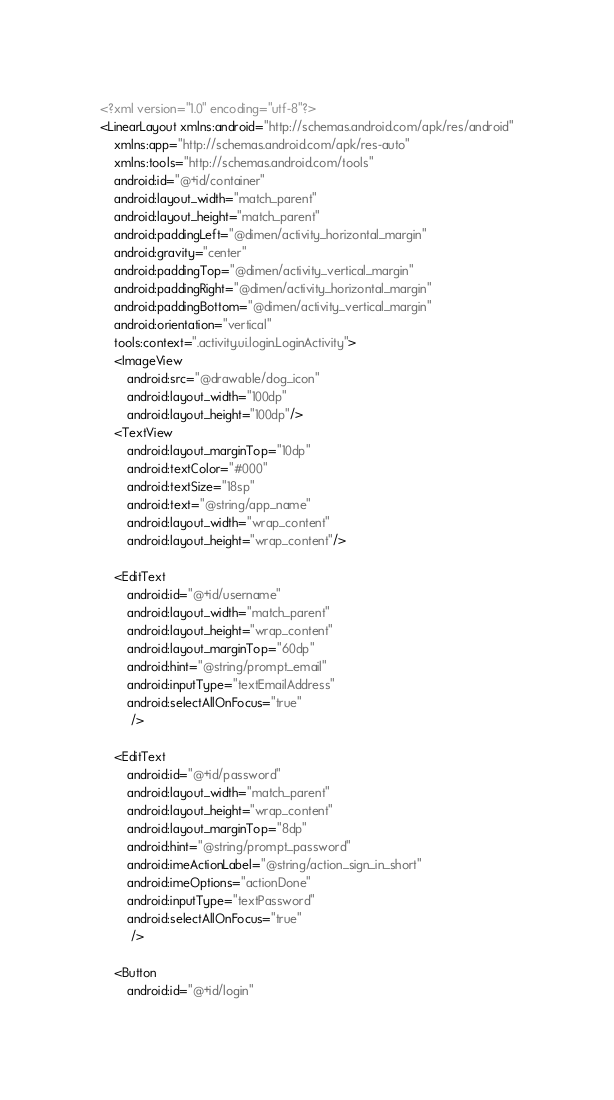Convert code to text. <code><loc_0><loc_0><loc_500><loc_500><_XML_><?xml version="1.0" encoding="utf-8"?>
<LinearLayout xmlns:android="http://schemas.android.com/apk/res/android"
    xmlns:app="http://schemas.android.com/apk/res-auto"
    xmlns:tools="http://schemas.android.com/tools"
    android:id="@+id/container"
    android:layout_width="match_parent"
    android:layout_height="match_parent"
    android:paddingLeft="@dimen/activity_horizontal_margin"
    android:gravity="center"
    android:paddingTop="@dimen/activity_vertical_margin"
    android:paddingRight="@dimen/activity_horizontal_margin"
    android:paddingBottom="@dimen/activity_vertical_margin"
    android:orientation="vertical"
    tools:context=".activity.ui.login.LoginActivity">
    <ImageView
        android:src="@drawable/dog_icon"
        android:layout_width="100dp"
        android:layout_height="100dp"/>
    <TextView
        android:layout_marginTop="10dp"
        android:textColor="#000"
        android:textSize="18sp"
        android:text="@string/app_name"
        android:layout_width="wrap_content"
        android:layout_height="wrap_content"/>

    <EditText
        android:id="@+id/username"
        android:layout_width="match_parent"
        android:layout_height="wrap_content"
        android:layout_marginTop="60dp"
        android:hint="@string/prompt_email"
        android:inputType="textEmailAddress"
        android:selectAllOnFocus="true"
         />

    <EditText
        android:id="@+id/password"
        android:layout_width="match_parent"
        android:layout_height="wrap_content"
        android:layout_marginTop="8dp"
        android:hint="@string/prompt_password"
        android:imeActionLabel="@string/action_sign_in_short"
        android:imeOptions="actionDone"
        android:inputType="textPassword"
        android:selectAllOnFocus="true"
         />

    <Button
        android:id="@+id/login"</code> 